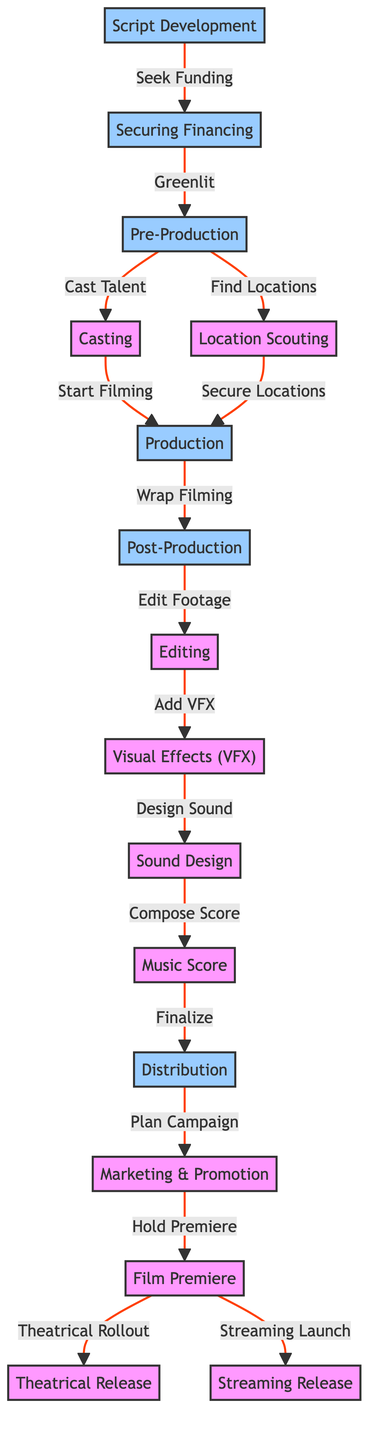What is the first step in the process flowchart? The diagram starts with the "Script Development" phase, indicating that this is where the process begins.
Answer: Script Development How many main phases are there in the diagram? The diagram includes four main phases: Script Development, Financing, Production, and Distribution. Counting these phases, we find that there are 4 main phases.
Answer: 4 What follows "Securing Financing"? After "Securing Financing," the diagram shows that it leads to "Pre-Production," indicating that this is the next step once financing is secured.
Answer: Pre-Production What processes occur during the "Post-Production" phase? In the "Post-Production" phase, the diagram lists three processes: "Editing," "Visual Effects (VFX)," and "Sound Design." Each of these processes is sequentially carried out within this phase.
Answer: Editing, Visual Effects (VFX), Sound Design Which two releases occur after the "Film Premiere"? The diagram illustrates that after the "Film Premiere," the "Theatrical Release" and "Streaming Release" occur. Both are shown as subsequent outputs of the premiere.
Answer: Theatrical Release, Streaming Release What key action initiates the "Production" phase? The "Production" phase is initiated by the actions from "Casting," which leads to "Start Filming," and from "Location Scouting," which leads to "Secure Locations." This indicates that both actions are necessary to start the production process.
Answer: Start Filming and Secure Locations How does "Editing" connect to "Distribution"? According to the flowchart, "Editing" leads to "Visual Effects (VFX)," which continues to "Sound Design," "Music Score," and finally connects to "Distribution," indicating a sequential flow where each step depends on the previous one.
Answer: Through Visual Effects (VFX), Sound Design, Music Score What occurs right after "Add VFX"? The diagram indicates that the action that follows "Add VFX" is "Design Sound," which is the next step in the post-production process.
Answer: Design Sound What is the primary purpose of the "Marketing & Promotion" phase? The purpose of the "Marketing & Promotion" phase is to promote the film and plan its release strategy. It acts as a preparatory step before the premiere of the film.
Answer: Plan Campaign 